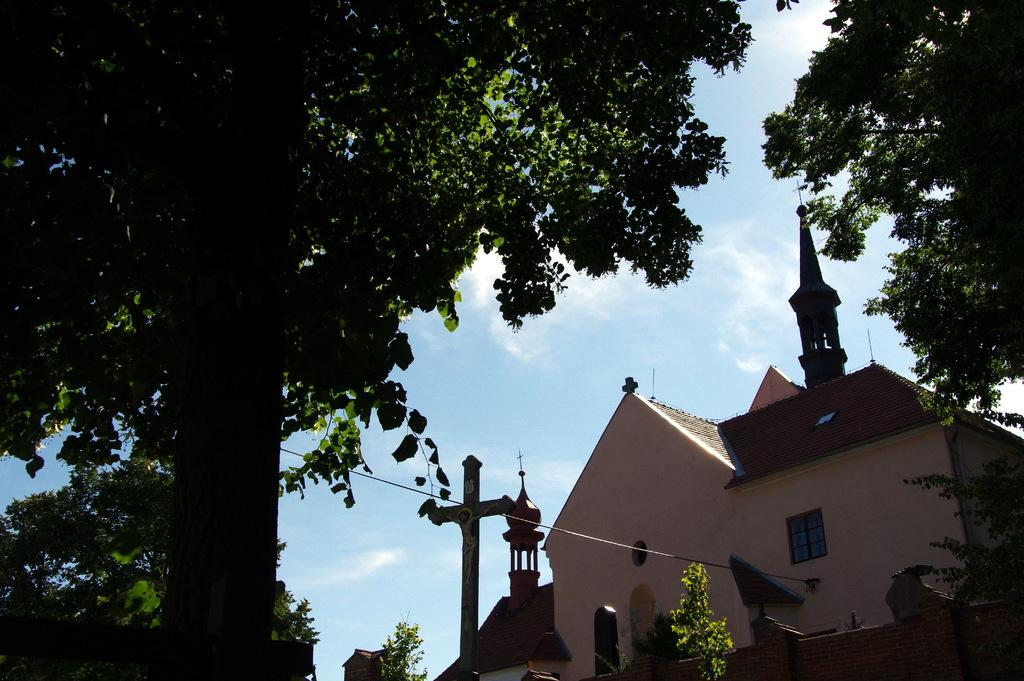What type of building is in the image? There is a church in the image. What can be seen surrounding the church? Large trees are around the church. What is visible in the background of the image? The sky is visible in the background of the image. What is the profit margin of the church in the image? There is no information about the profit margin of the church in the image, as churches are typically non-profit organizations. 